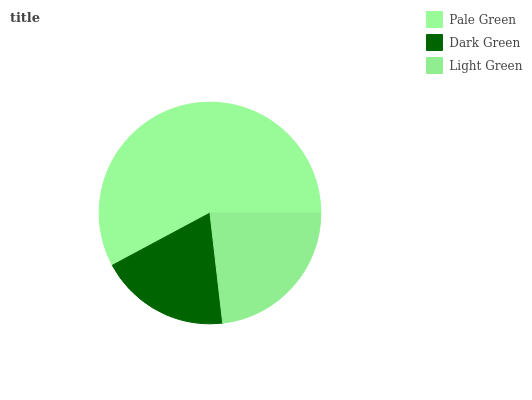Is Dark Green the minimum?
Answer yes or no. Yes. Is Pale Green the maximum?
Answer yes or no. Yes. Is Light Green the minimum?
Answer yes or no. No. Is Light Green the maximum?
Answer yes or no. No. Is Light Green greater than Dark Green?
Answer yes or no. Yes. Is Dark Green less than Light Green?
Answer yes or no. Yes. Is Dark Green greater than Light Green?
Answer yes or no. No. Is Light Green less than Dark Green?
Answer yes or no. No. Is Light Green the high median?
Answer yes or no. Yes. Is Light Green the low median?
Answer yes or no. Yes. Is Dark Green the high median?
Answer yes or no. No. Is Pale Green the low median?
Answer yes or no. No. 